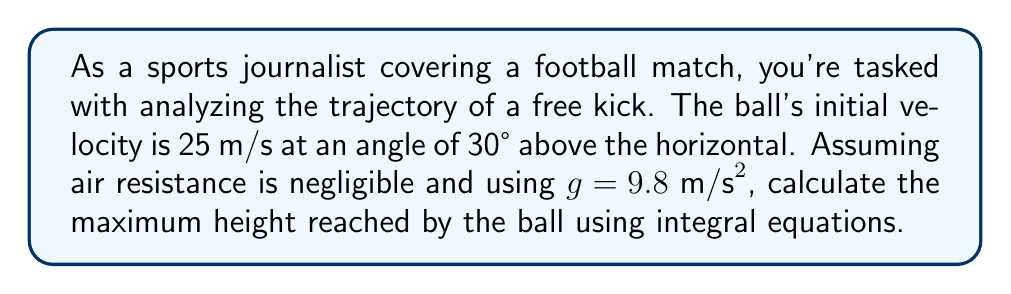Give your solution to this math problem. Let's approach this step-by-step:

1) First, we need to break down the initial velocity into its vertical and horizontal components:
   $v_{0x} = 25 \cos(30°) = 21.65 \text{ m/s}$
   $v_{0y} = 25 \sin(30°) = 12.5 \text{ m/s}$

2) The vertical motion is what we're interested in for the maximum height. The acceleration in the y-direction is $-g = -9.8 \text{ m/s}^2$.

3) We know that velocity is the derivative of position with respect to time, and acceleration is the derivative of velocity with respect to time. So:

   $$\frac{dv_y}{dt} = -g$$

4) Integrating both sides with respect to time:

   $$\int dv_y = \int -g dt$$
   $$v_y = -gt + C$$

5) At $t=0$, $v_y = v_{0y} = 12.5 \text{ m/s}$, so $C = 12.5$. Thus:

   $$v_y = -9.8t + 12.5$$

6) Now, we can find the time when the ball reaches its maximum height. This occurs when $v_y = 0$:

   $$0 = -9.8t + 12.5$$
   $$t = \frac{12.5}{9.8} = 1.28 \text{ seconds}$$

7) To find the height, we integrate the velocity equation:

   $$\int v_y dt = \int (-9.8t + 12.5) dt$$
   $$y = -4.9t^2 + 12.5t + D$$

8) At $t=0$, $y=0$, so $D=0$. Therefore:

   $$y = -4.9t^2 + 12.5t$$

9) Substituting $t = 1.28$ into this equation:

   $$y_{\text{max}} = -4.9(1.28)^2 + 12.5(1.28) = 7.97 \text{ meters}$$

Thus, the maximum height reached by the ball is approximately 7.97 meters.
Answer: 7.97 meters 